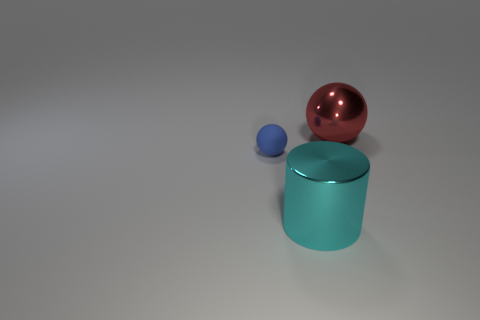How many other things are the same color as the big sphere?
Offer a terse response. 0. Do the red ball that is behind the cyan shiny cylinder and the blue object have the same material?
Make the answer very short. No. What material is the big object that is behind the cyan metallic thing?
Keep it short and to the point. Metal. There is a ball left of the cylinder in front of the red shiny object; what size is it?
Offer a terse response. Small. Is there a large blue thing that has the same material as the red object?
Ensure brevity in your answer.  No. The metal thing that is on the left side of the big object that is to the right of the large metal object to the left of the large ball is what shape?
Give a very brief answer. Cylinder. Is the color of the object that is behind the small blue matte sphere the same as the object on the left side of the cyan thing?
Keep it short and to the point. No. Are there any other things that have the same size as the red metal object?
Provide a short and direct response. Yes. Are there any big cyan shiny objects in front of the big cyan object?
Ensure brevity in your answer.  No. What number of tiny blue matte objects have the same shape as the big cyan metal object?
Ensure brevity in your answer.  0. 